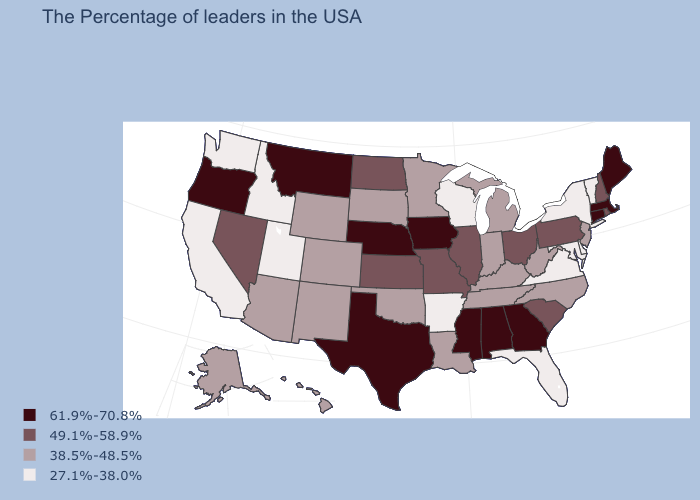Is the legend a continuous bar?
Quick response, please. No. Does New Mexico have a lower value than Maine?
Short answer required. Yes. What is the highest value in states that border Kansas?
Give a very brief answer. 61.9%-70.8%. Name the states that have a value in the range 27.1%-38.0%?
Be succinct. Vermont, New York, Delaware, Maryland, Virginia, Florida, Wisconsin, Arkansas, Utah, Idaho, California, Washington. What is the value of Massachusetts?
Short answer required. 61.9%-70.8%. Does the first symbol in the legend represent the smallest category?
Short answer required. No. What is the lowest value in the USA?
Write a very short answer. 27.1%-38.0%. Is the legend a continuous bar?
Concise answer only. No. Name the states that have a value in the range 61.9%-70.8%?
Give a very brief answer. Maine, Massachusetts, Connecticut, Georgia, Alabama, Mississippi, Iowa, Nebraska, Texas, Montana, Oregon. What is the value of California?
Quick response, please. 27.1%-38.0%. Among the states that border Idaho , which have the highest value?
Write a very short answer. Montana, Oregon. Does Arkansas have the lowest value in the USA?
Write a very short answer. Yes. What is the value of Florida?
Be succinct. 27.1%-38.0%. Is the legend a continuous bar?
Keep it brief. No. Name the states that have a value in the range 27.1%-38.0%?
Answer briefly. Vermont, New York, Delaware, Maryland, Virginia, Florida, Wisconsin, Arkansas, Utah, Idaho, California, Washington. 